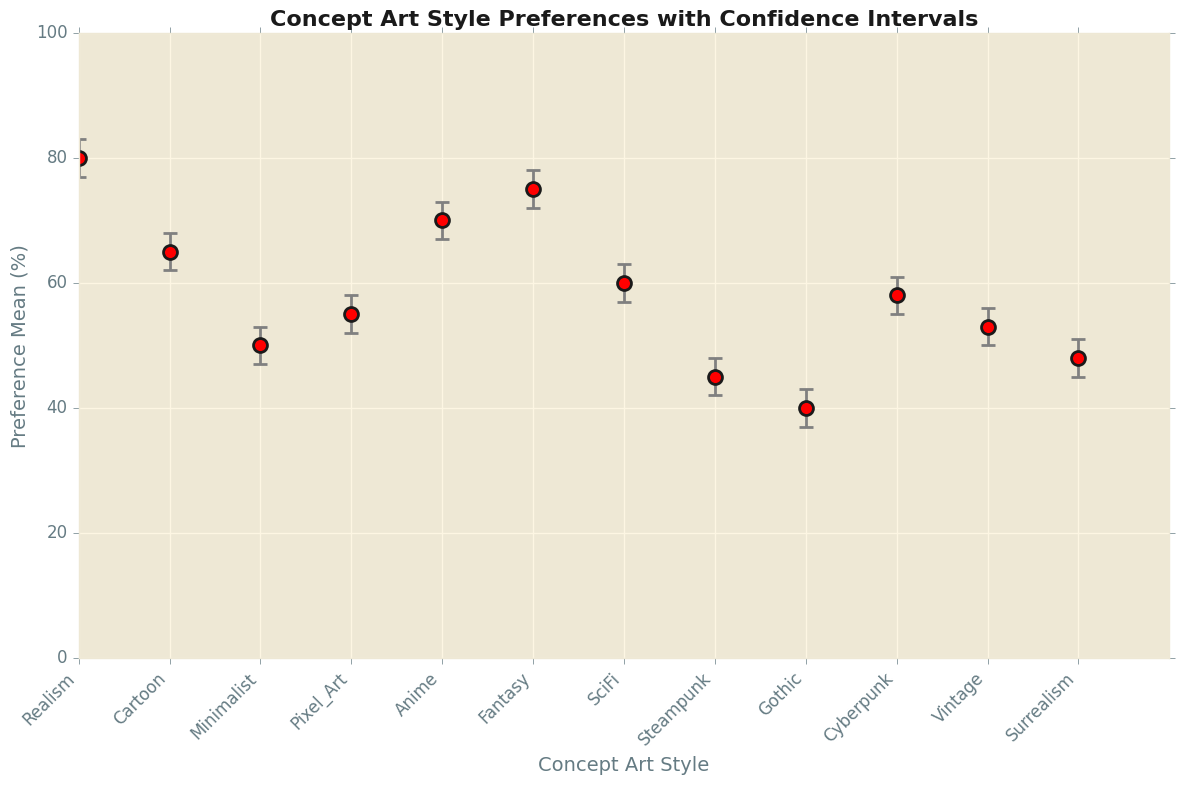What concept art style has the highest preference mean? To identify the highest preference mean, look for the highest point on the y-axis. Realism has the highest value at 80%.
Answer: Realism What is the difference in preference mean between Realism and Steampunk? Realism has a preference mean of 80% and Steampunk has 45%. The difference is 80 - 45.
Answer: 35 Which concept art style has the smallest confidence interval range? The confidence interval range is the upper limit minus the lower limit. Compare these ranges for each style. Cartoon has the smallest range of 68 - 62 = 6.
Answer: Cartoon How many styles have a preference mean of 60% or higher? Count the styles with a preference mean of 60% or higher by checking the y-axis values. Realism, Anime, Fantasy, Cartoon, and SciFi meet the criteria.
Answer: 5 What is the average preference mean of the styles with preference means under 50%? The relevant styles are Steampunk, Gothic, and Surrealism with means 45, 40, and 48 respectively. The average is (45 + 40 + 48) / 3.
Answer: 44.3 Between Anime and Cyberpunk, which has a higher preference mean and by how much? Anime has a preference mean of 70%, while Cyberpunk has 58%. Subtract Cyberpunk's mean from Anime's mean.
Answer: Anime by 12% What style has the largest upper confidence interval and what is its value? Find the highest point in the confidence interval upper limits. Realism has the highest upper limit at 83%.
Answer: Realism, 83% Are there any styles where the entire confidence interval falls below 50%? Check if the upper limit of any style's confidence interval is less than 50%. Only Gothic's upper limit is 43, which is under 50%.
Answer: Gothic What is the combined range of confidence intervals for Fantasy and Pixel Art? Find the range for each: Fantasy (78 - 72) = 6 and Pixel Art (58 - 52) = 6, then add the ranges.
Answer: 12 Which style with a mean of 60% or more has the largest confidence interval lower limit? Compare the lower limits for styles with means above 60%. Realism has the highest lower limit at 77%.
Answer: Realism 